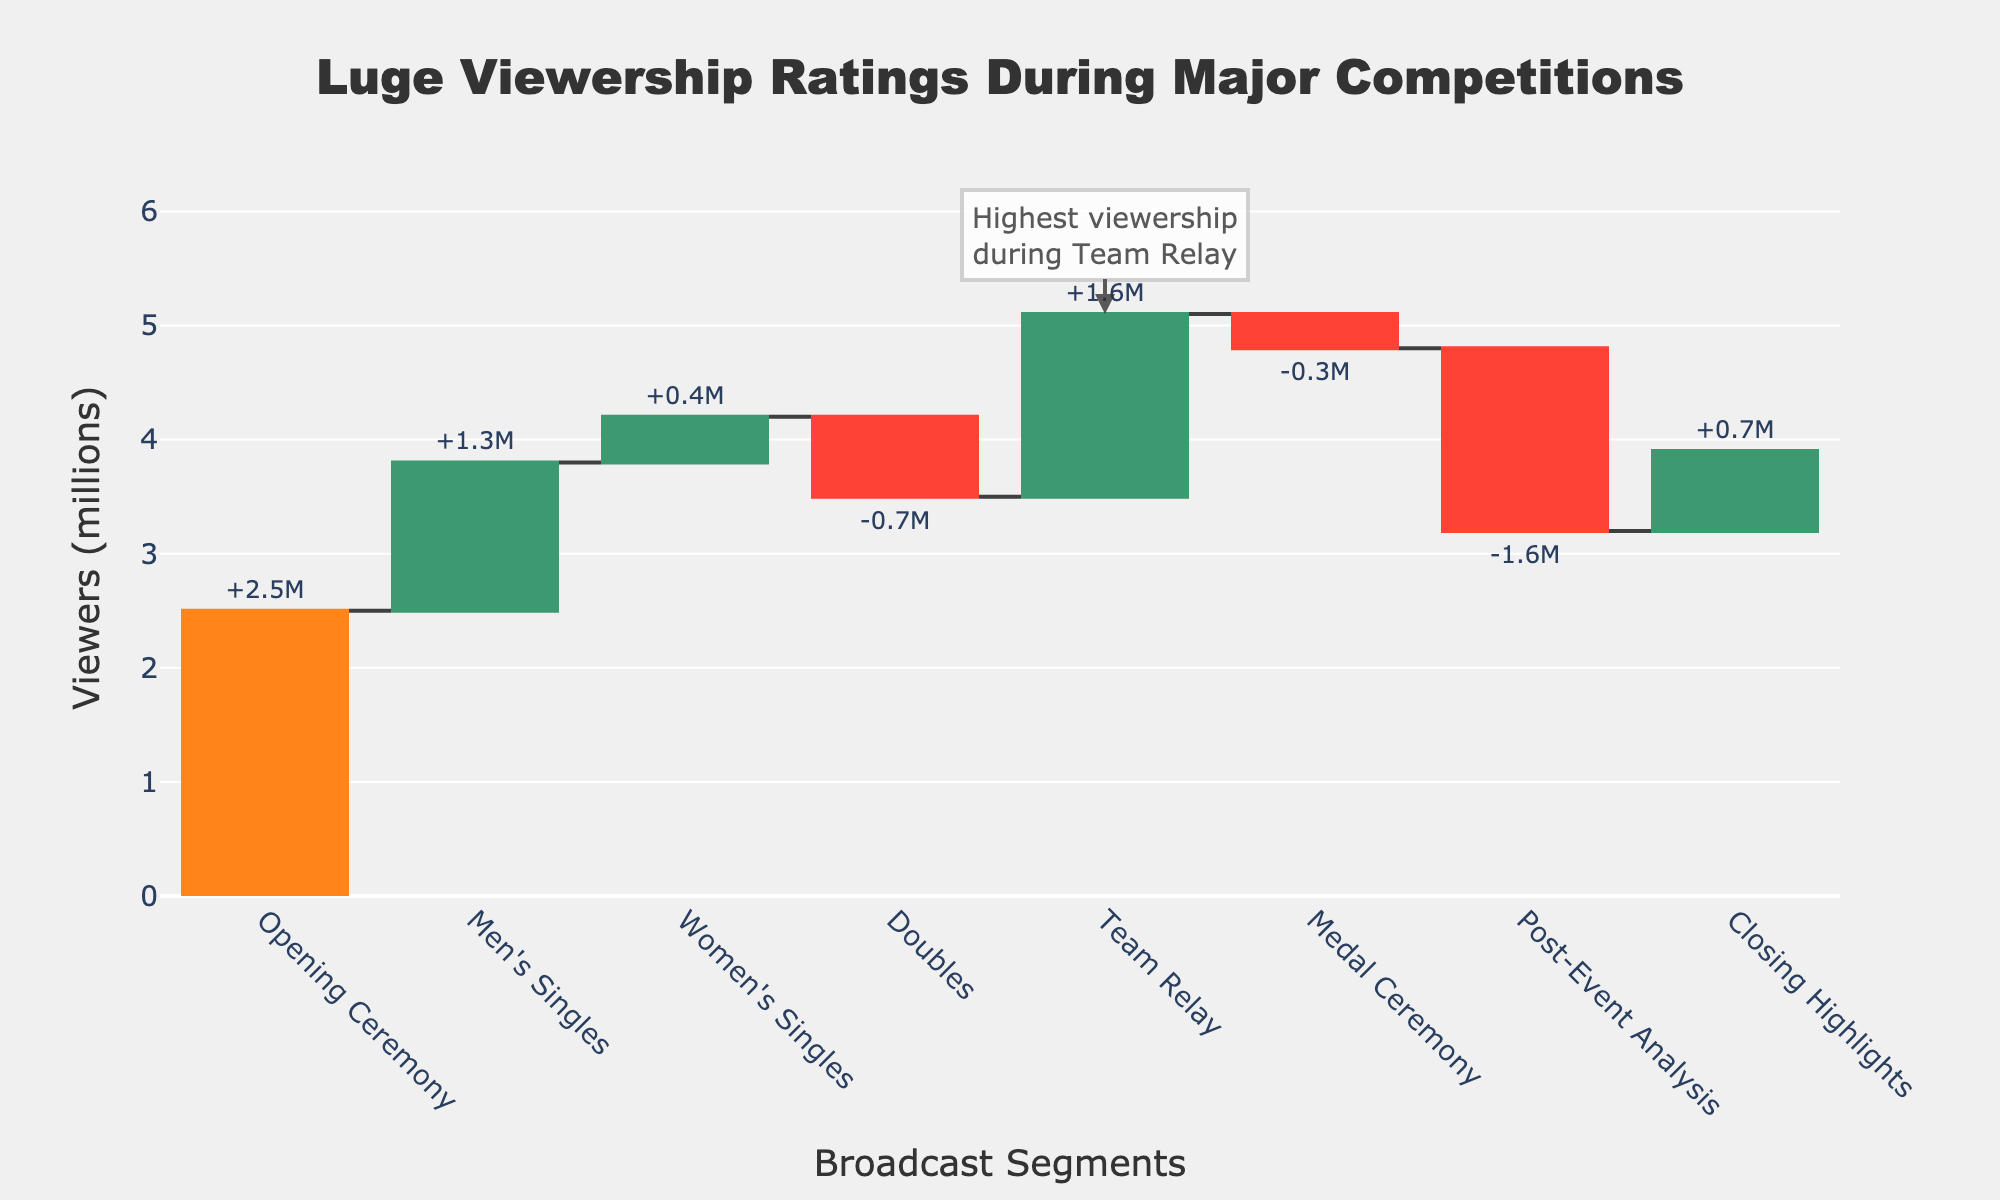What's the title of the figure? The title is shown at the top of the figure.
Answer: Luge Viewership Ratings During Major Competitions What segment had the highest viewership? The segment with the highest viewership has the largest value on the y-axis and is highlighted by an annotation in the figure.
Answer: Team Relay How many segments experienced a decrease in viewership? Count the segments where the change bars are marked in red, indicating a decrease.
Answer: 3 Which segment had the largest increase in viewership? Look for the segment with the tallest green bar, which shows the highest positive change.
Answer: Team Relay What is the total viewership at the end of the Men's Singles segment? Add the viewership for the Opening Ceremony to the change during Men's Singles.
Answer: 2.5M + 1.3M = 3.8M Did the Medal Ceremony witness an increase or decrease in viewership? Observe whether the Medal Ceremony bar is green (increase) or red (decrease).
Answer: Decrease What was the change in viewership during the Doubles segment? Look at the figure for the Doubles segment and note the value labeled on the bar.
Answer: -0.7M How does the final viewership of the Post-Event Analysis segment compare to the Opening Ceremony segment? Compare the viewership values shown for the Post-Event Analysis and Opening Ceremony segments.
Answer: Post-Event Analysis (3.2M) is higher than Opening Ceremony (2.5M) What is the viewership difference between Team Relay and Women's Singles? Subtract the viewership of Women's Singles from Team Relay.
Answer: 5.1M - 4.2M = 0.9M Summarize the trend in viewership from the Opening Ceremony to the Medal Ceremony. Note the overall increase or decrease by observing the trend in the changes from Opening Ceremony to Medal Ceremony.
Answer: General increase with fluctuations 